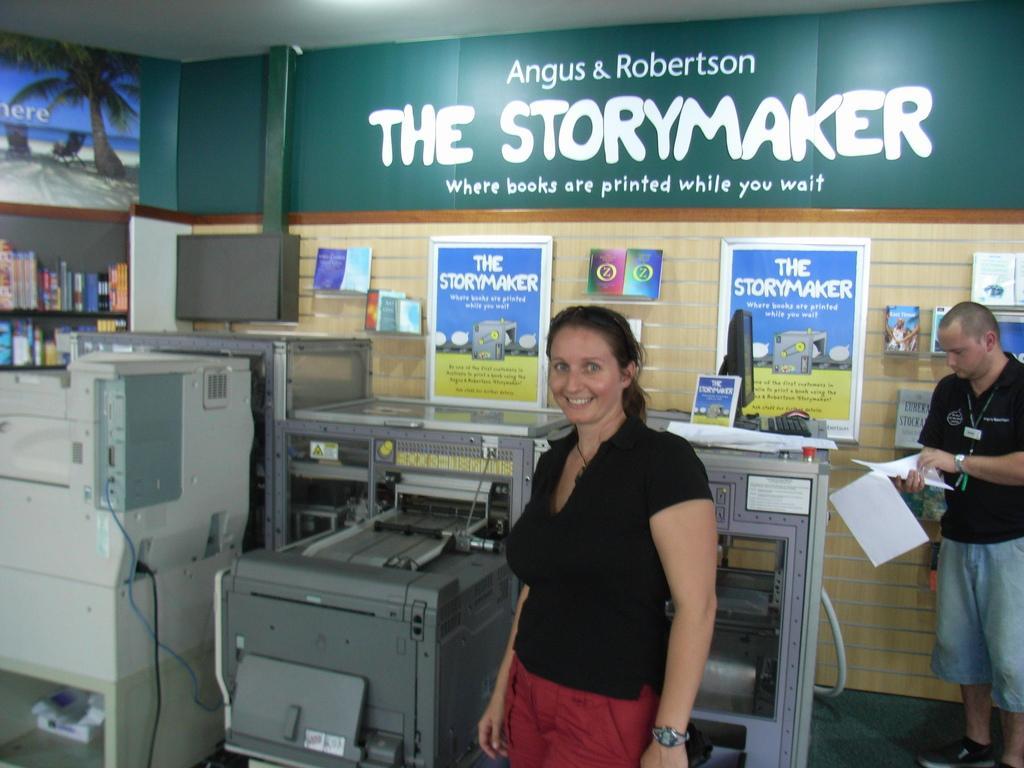Can you describe this image briefly? In this image there is a woman standing, there is a man standing towards the right of the image, he is holding papers, there are machines that look like a xerox machine, there is the wall, there are objects on the wall, there is board, there is text on the board, there is a shelf towards the left of the image, there are books on the shelf, there is the roof towards the top of the image. 